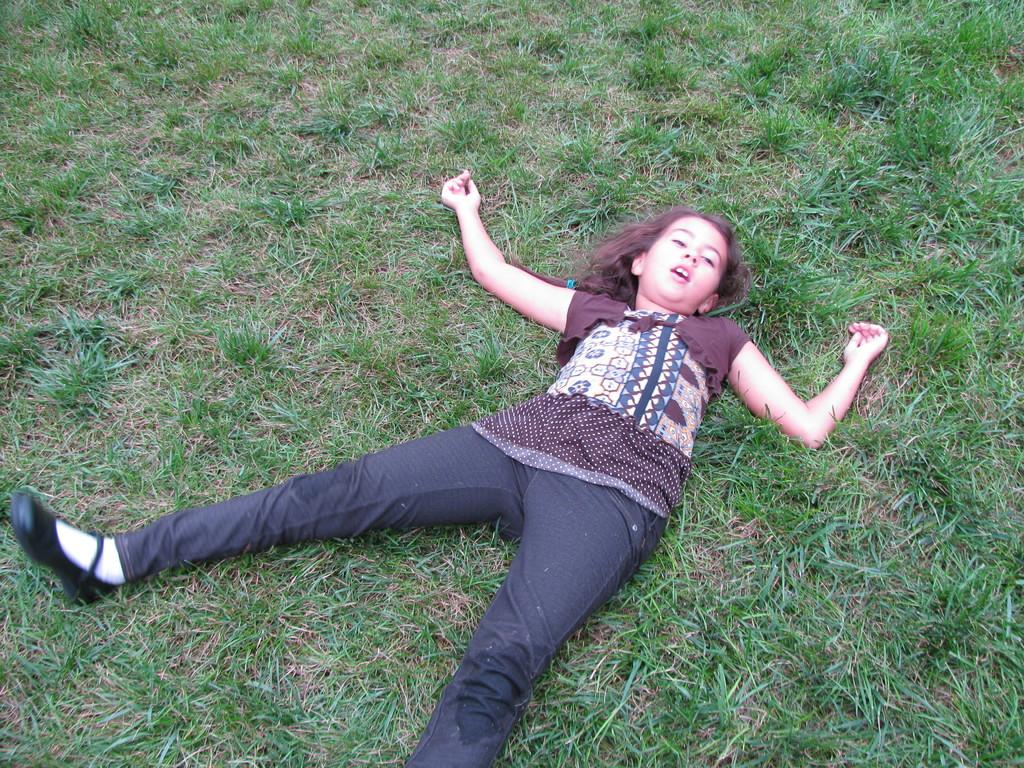Who is the main subject in the image? There is a girl in the image. What is the girl doing in the image? The girl is lying on the grass. What type of mailbox can be seen near the girl in the image? There is no mailbox present in the image. How does the sleet affect the girl's position on the grass in the image? There is no sleet present in the image, so it does not affect the girl's position. 